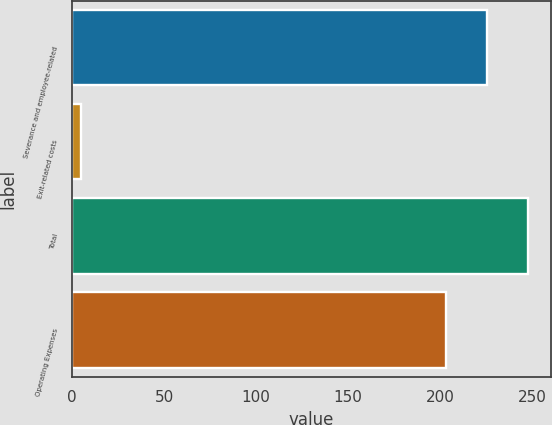Convert chart. <chart><loc_0><loc_0><loc_500><loc_500><bar_chart><fcel>Severance and employee-related<fcel>Exit-related costs<fcel>Total<fcel>Operating Expenses<nl><fcel>225.4<fcel>5<fcel>247.8<fcel>203<nl></chart> 